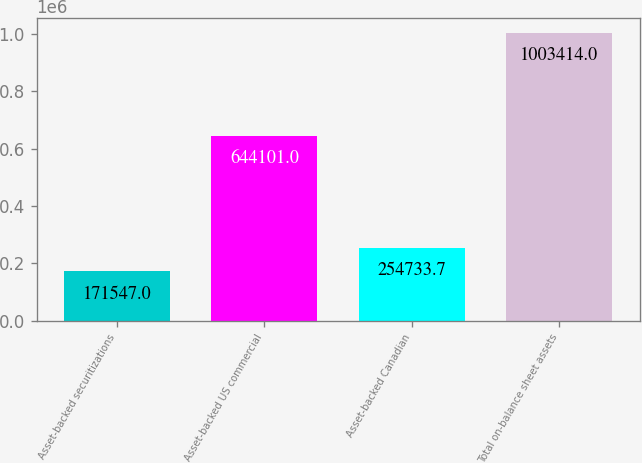<chart> <loc_0><loc_0><loc_500><loc_500><bar_chart><fcel>Asset-backed securitizations<fcel>Asset-backed US commercial<fcel>Asset-backed Canadian<fcel>Total on-balance sheet assets<nl><fcel>171547<fcel>644101<fcel>254734<fcel>1.00341e+06<nl></chart> 